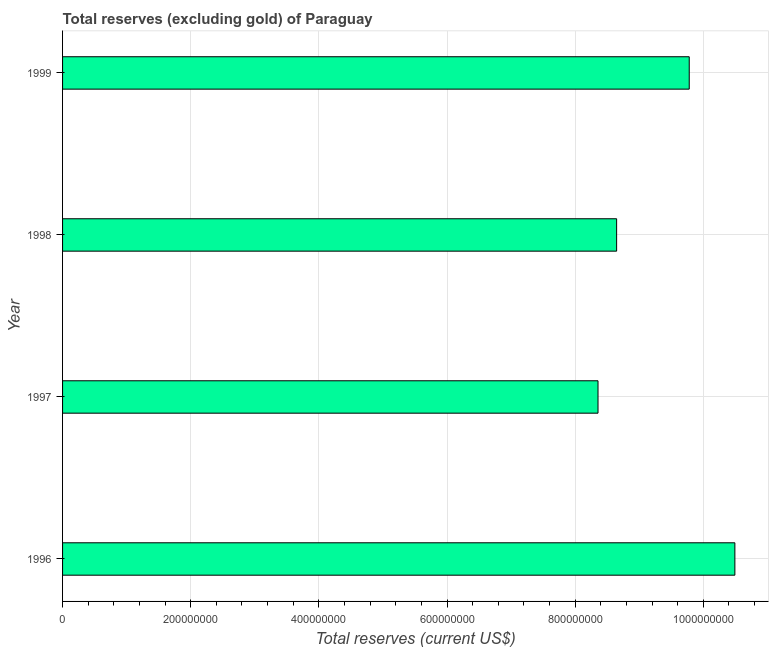Does the graph contain any zero values?
Your response must be concise. No. What is the title of the graph?
Offer a terse response. Total reserves (excluding gold) of Paraguay. What is the label or title of the X-axis?
Offer a terse response. Total reserves (current US$). What is the label or title of the Y-axis?
Make the answer very short. Year. What is the total reserves (excluding gold) in 1999?
Provide a succinct answer. 9.78e+08. Across all years, what is the maximum total reserves (excluding gold)?
Offer a very short reply. 1.05e+09. Across all years, what is the minimum total reserves (excluding gold)?
Your answer should be compact. 8.36e+08. In which year was the total reserves (excluding gold) maximum?
Give a very brief answer. 1996. What is the sum of the total reserves (excluding gold)?
Your answer should be compact. 3.73e+09. What is the difference between the total reserves (excluding gold) in 1996 and 1998?
Make the answer very short. 1.85e+08. What is the average total reserves (excluding gold) per year?
Offer a very short reply. 9.32e+08. What is the median total reserves (excluding gold)?
Your answer should be very brief. 9.21e+08. Do a majority of the years between 1997 and 1996 (inclusive) have total reserves (excluding gold) greater than 320000000 US$?
Offer a very short reply. No. What is the ratio of the total reserves (excluding gold) in 1996 to that in 1997?
Provide a short and direct response. 1.26. Is the difference between the total reserves (excluding gold) in 1996 and 1999 greater than the difference between any two years?
Ensure brevity in your answer.  No. What is the difference between the highest and the second highest total reserves (excluding gold)?
Your answer should be compact. 7.12e+07. Is the sum of the total reserves (excluding gold) in 1998 and 1999 greater than the maximum total reserves (excluding gold) across all years?
Your answer should be compact. Yes. What is the difference between the highest and the lowest total reserves (excluding gold)?
Your answer should be very brief. 2.14e+08. In how many years, is the total reserves (excluding gold) greater than the average total reserves (excluding gold) taken over all years?
Your answer should be very brief. 2. What is the difference between two consecutive major ticks on the X-axis?
Your answer should be compact. 2.00e+08. Are the values on the major ticks of X-axis written in scientific E-notation?
Provide a succinct answer. No. What is the Total reserves (current US$) in 1996?
Provide a succinct answer. 1.05e+09. What is the Total reserves (current US$) of 1997?
Your answer should be compact. 8.36e+08. What is the Total reserves (current US$) in 1998?
Give a very brief answer. 8.65e+08. What is the Total reserves (current US$) in 1999?
Your answer should be very brief. 9.78e+08. What is the difference between the Total reserves (current US$) in 1996 and 1997?
Your response must be concise. 2.14e+08. What is the difference between the Total reserves (current US$) in 1996 and 1998?
Your answer should be compact. 1.85e+08. What is the difference between the Total reserves (current US$) in 1996 and 1999?
Keep it short and to the point. 7.12e+07. What is the difference between the Total reserves (current US$) in 1997 and 1998?
Ensure brevity in your answer.  -2.91e+07. What is the difference between the Total reserves (current US$) in 1997 and 1999?
Your answer should be very brief. -1.42e+08. What is the difference between the Total reserves (current US$) in 1998 and 1999?
Make the answer very short. -1.13e+08. What is the ratio of the Total reserves (current US$) in 1996 to that in 1997?
Your answer should be very brief. 1.26. What is the ratio of the Total reserves (current US$) in 1996 to that in 1998?
Keep it short and to the point. 1.21. What is the ratio of the Total reserves (current US$) in 1996 to that in 1999?
Make the answer very short. 1.07. What is the ratio of the Total reserves (current US$) in 1997 to that in 1998?
Your answer should be compact. 0.97. What is the ratio of the Total reserves (current US$) in 1997 to that in 1999?
Provide a succinct answer. 0.85. What is the ratio of the Total reserves (current US$) in 1998 to that in 1999?
Your answer should be very brief. 0.88. 